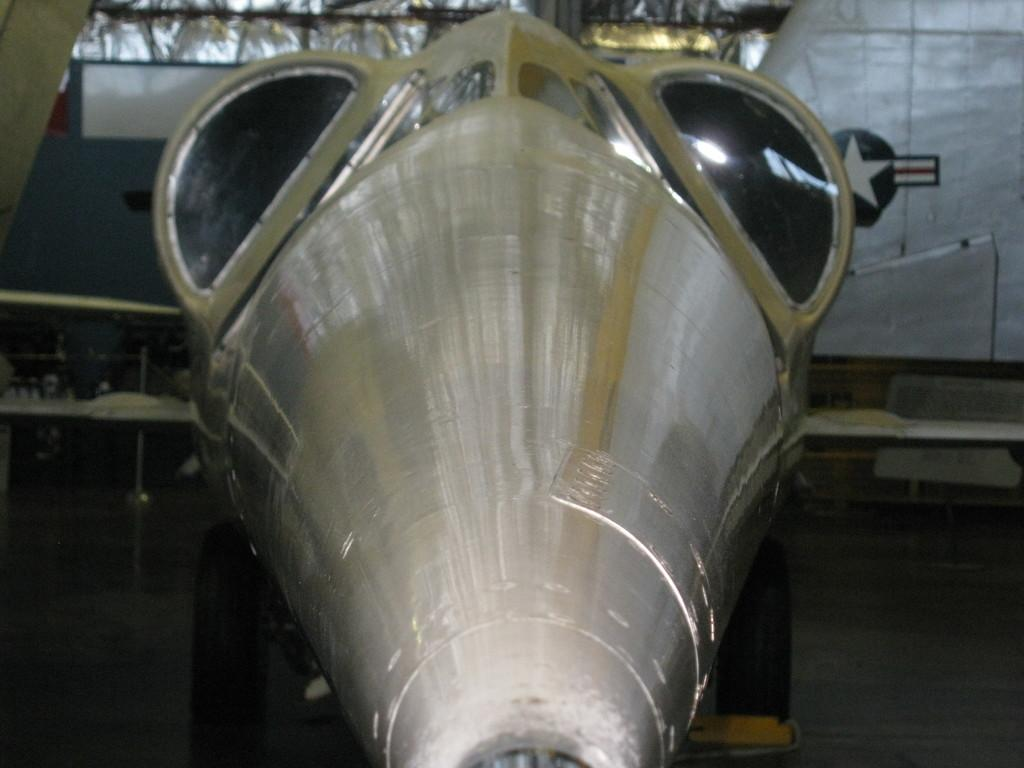What type of object is present in the image? There is a metal object in the image. Can you describe anything in the background of the image? Yes, there is a logo visible in the background of the image. Are there any other objects in the background besides the logo? Yes, there are some unspecified objects in the background of the image. How many bells are hanging from the metal object in the image? There are no bells present in the image; it only features a metal object and a background with a logo and unspecified objects. 